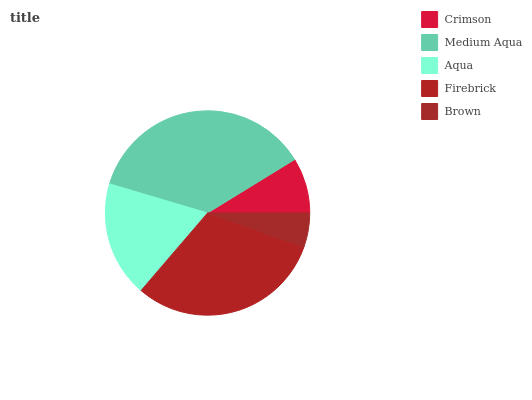Is Brown the minimum?
Answer yes or no. Yes. Is Medium Aqua the maximum?
Answer yes or no. Yes. Is Aqua the minimum?
Answer yes or no. No. Is Aqua the maximum?
Answer yes or no. No. Is Medium Aqua greater than Aqua?
Answer yes or no. Yes. Is Aqua less than Medium Aqua?
Answer yes or no. Yes. Is Aqua greater than Medium Aqua?
Answer yes or no. No. Is Medium Aqua less than Aqua?
Answer yes or no. No. Is Aqua the high median?
Answer yes or no. Yes. Is Aqua the low median?
Answer yes or no. Yes. Is Medium Aqua the high median?
Answer yes or no. No. Is Crimson the low median?
Answer yes or no. No. 